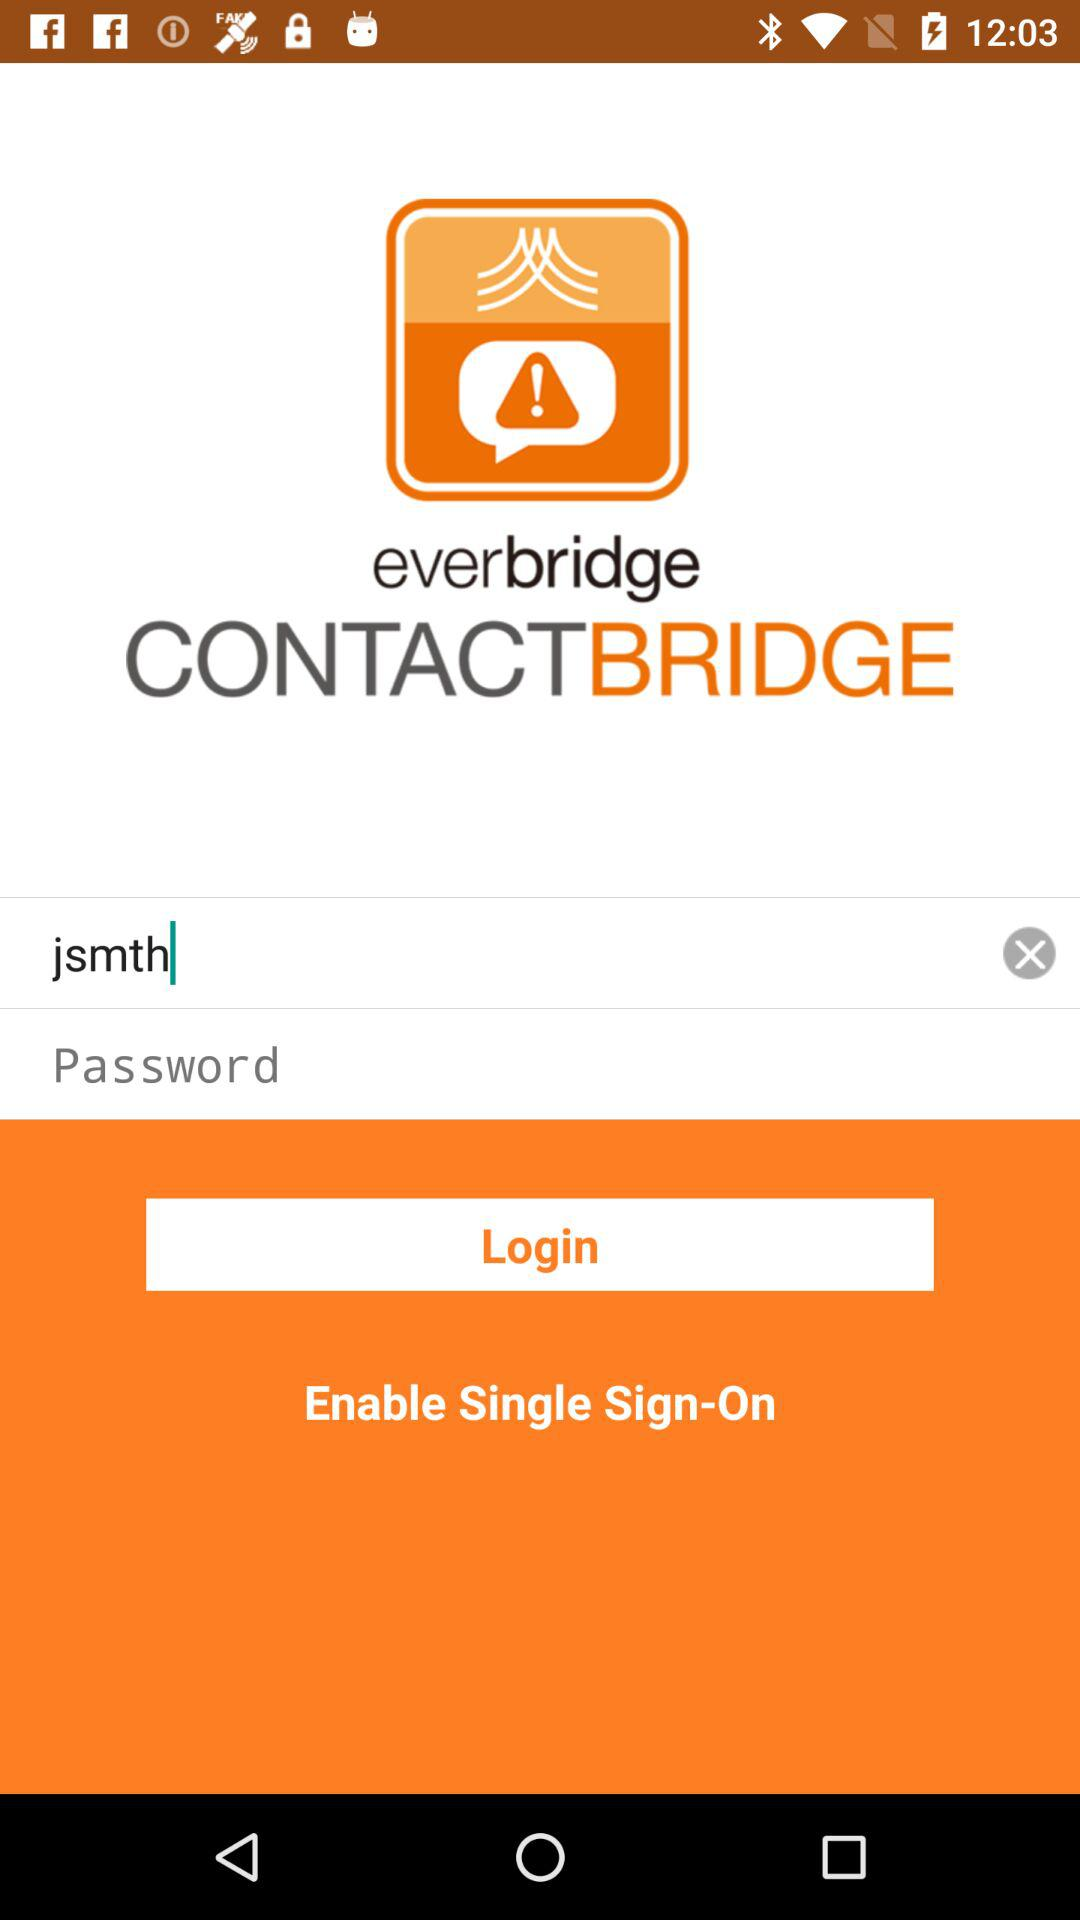What is the username? The username is "jsmth". 